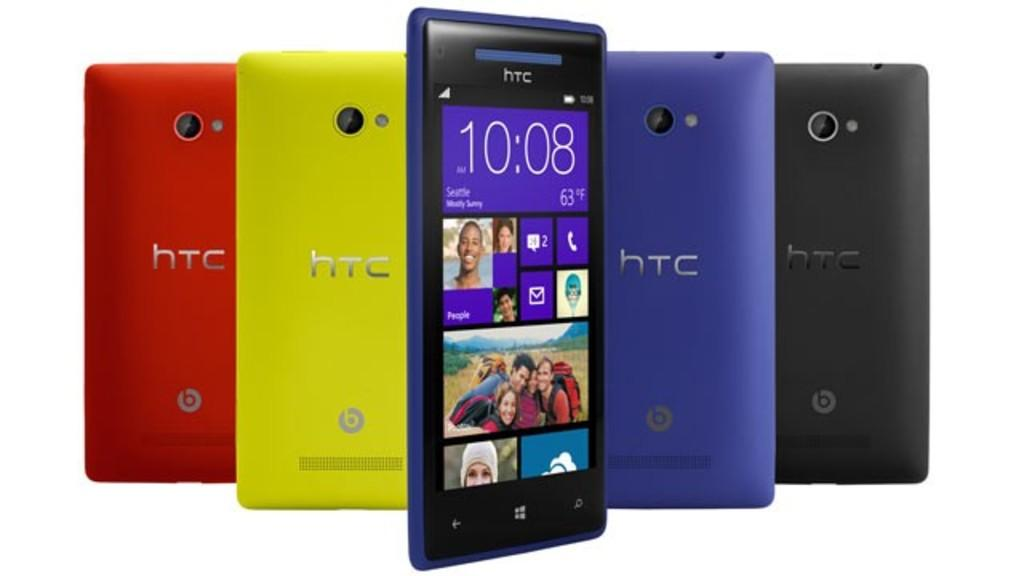Provide a one-sentence caption for the provided image. a display of various colors of HTC cell phones. 